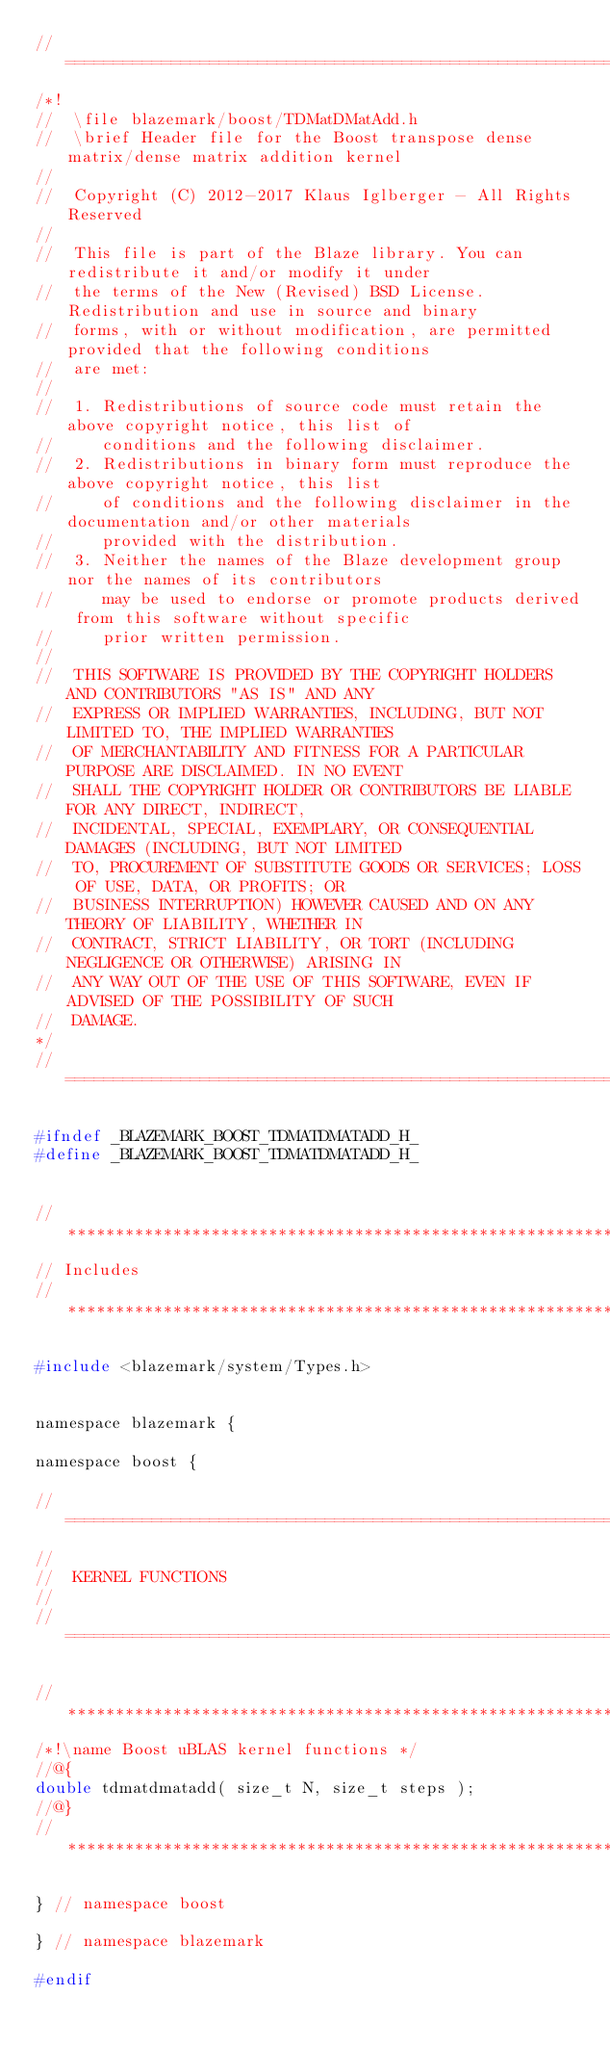<code> <loc_0><loc_0><loc_500><loc_500><_C_>//=================================================================================================
/*!
//  \file blazemark/boost/TDMatDMatAdd.h
//  \brief Header file for the Boost transpose dense matrix/dense matrix addition kernel
//
//  Copyright (C) 2012-2017 Klaus Iglberger - All Rights Reserved
//
//  This file is part of the Blaze library. You can redistribute it and/or modify it under
//  the terms of the New (Revised) BSD License. Redistribution and use in source and binary
//  forms, with or without modification, are permitted provided that the following conditions
//  are met:
//
//  1. Redistributions of source code must retain the above copyright notice, this list of
//     conditions and the following disclaimer.
//  2. Redistributions in binary form must reproduce the above copyright notice, this list
//     of conditions and the following disclaimer in the documentation and/or other materials
//     provided with the distribution.
//  3. Neither the names of the Blaze development group nor the names of its contributors
//     may be used to endorse or promote products derived from this software without specific
//     prior written permission.
//
//  THIS SOFTWARE IS PROVIDED BY THE COPYRIGHT HOLDERS AND CONTRIBUTORS "AS IS" AND ANY
//  EXPRESS OR IMPLIED WARRANTIES, INCLUDING, BUT NOT LIMITED TO, THE IMPLIED WARRANTIES
//  OF MERCHANTABILITY AND FITNESS FOR A PARTICULAR PURPOSE ARE DISCLAIMED. IN NO EVENT
//  SHALL THE COPYRIGHT HOLDER OR CONTRIBUTORS BE LIABLE FOR ANY DIRECT, INDIRECT,
//  INCIDENTAL, SPECIAL, EXEMPLARY, OR CONSEQUENTIAL DAMAGES (INCLUDING, BUT NOT LIMITED
//  TO, PROCUREMENT OF SUBSTITUTE GOODS OR SERVICES; LOSS OF USE, DATA, OR PROFITS; OR
//  BUSINESS INTERRUPTION) HOWEVER CAUSED AND ON ANY THEORY OF LIABILITY, WHETHER IN
//  CONTRACT, STRICT LIABILITY, OR TORT (INCLUDING NEGLIGENCE OR OTHERWISE) ARISING IN
//  ANY WAY OUT OF THE USE OF THIS SOFTWARE, EVEN IF ADVISED OF THE POSSIBILITY OF SUCH
//  DAMAGE.
*/
//=================================================================================================

#ifndef _BLAZEMARK_BOOST_TDMATDMATADD_H_
#define _BLAZEMARK_BOOST_TDMATDMATADD_H_


//*************************************************************************************************
// Includes
//*************************************************************************************************

#include <blazemark/system/Types.h>


namespace blazemark {

namespace boost {

//=================================================================================================
//
//  KERNEL FUNCTIONS
//
//=================================================================================================

//*************************************************************************************************
/*!\name Boost uBLAS kernel functions */
//@{
double tdmatdmatadd( size_t N, size_t steps );
//@}
//*************************************************************************************************

} // namespace boost

} // namespace blazemark

#endif
</code> 